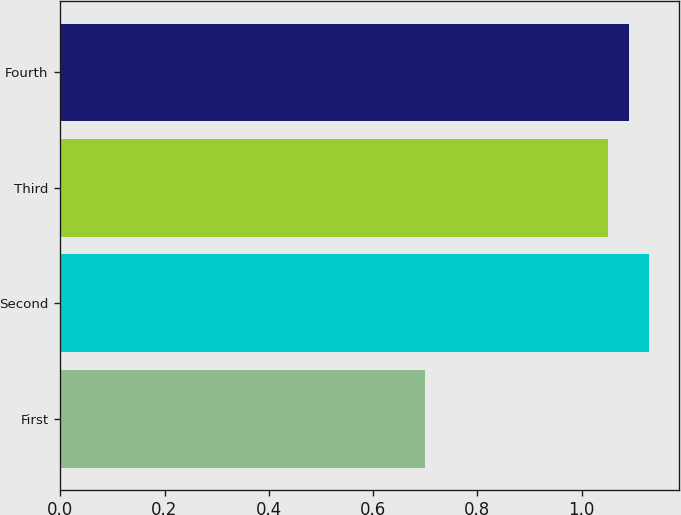<chart> <loc_0><loc_0><loc_500><loc_500><bar_chart><fcel>First<fcel>Second<fcel>Third<fcel>Fourth<nl><fcel>0.7<fcel>1.13<fcel>1.05<fcel>1.09<nl></chart> 